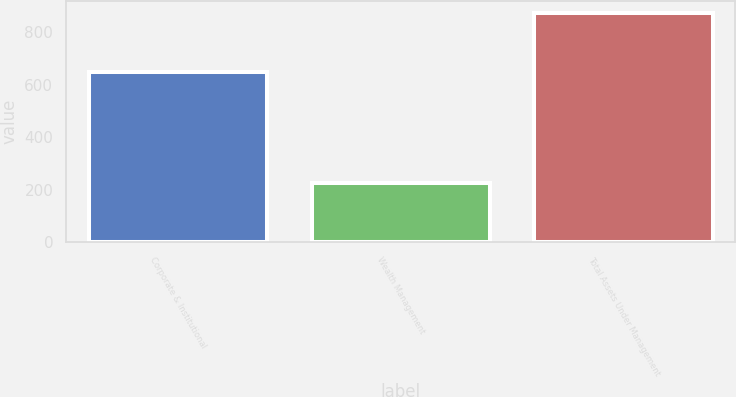Convert chart. <chart><loc_0><loc_0><loc_500><loc_500><bar_chart><fcel>Corporate & Institutional<fcel>Wealth Management<fcel>Total Assets Under Management<nl><fcel>648<fcel>227.3<fcel>875.3<nl></chart> 